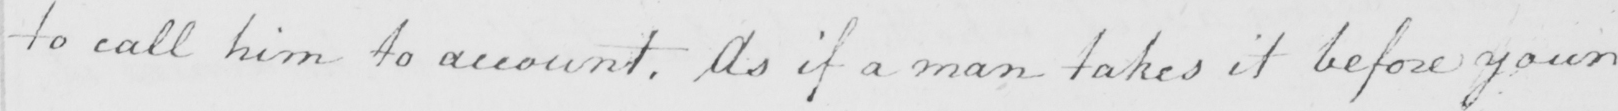Transcribe the text shown in this historical manuscript line. to call him to account . As if a man takes it before your 